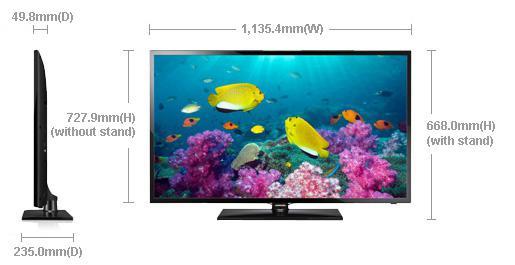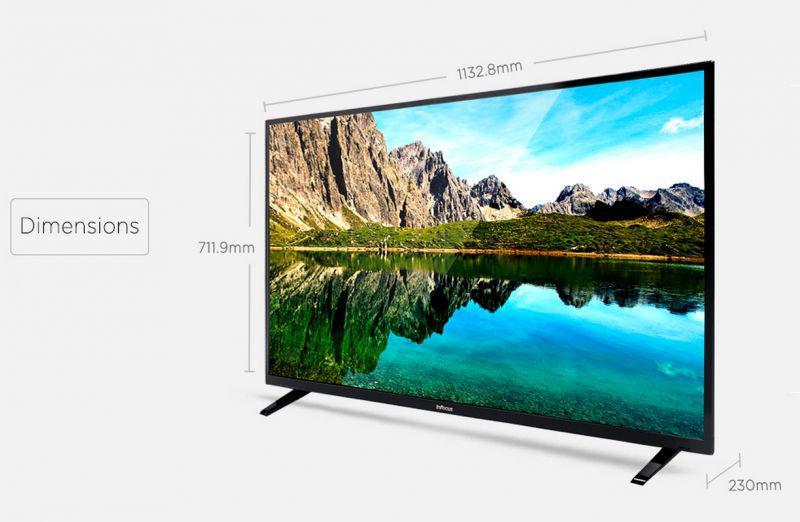The first image is the image on the left, the second image is the image on the right. For the images displayed, is the sentence "there is a sun glare in a monitor" factually correct? Answer yes or no. No. The first image is the image on the left, the second image is the image on the right. Assess this claim about the two images: "The television on the left has leg stands.". Correct or not? Answer yes or no. No. 